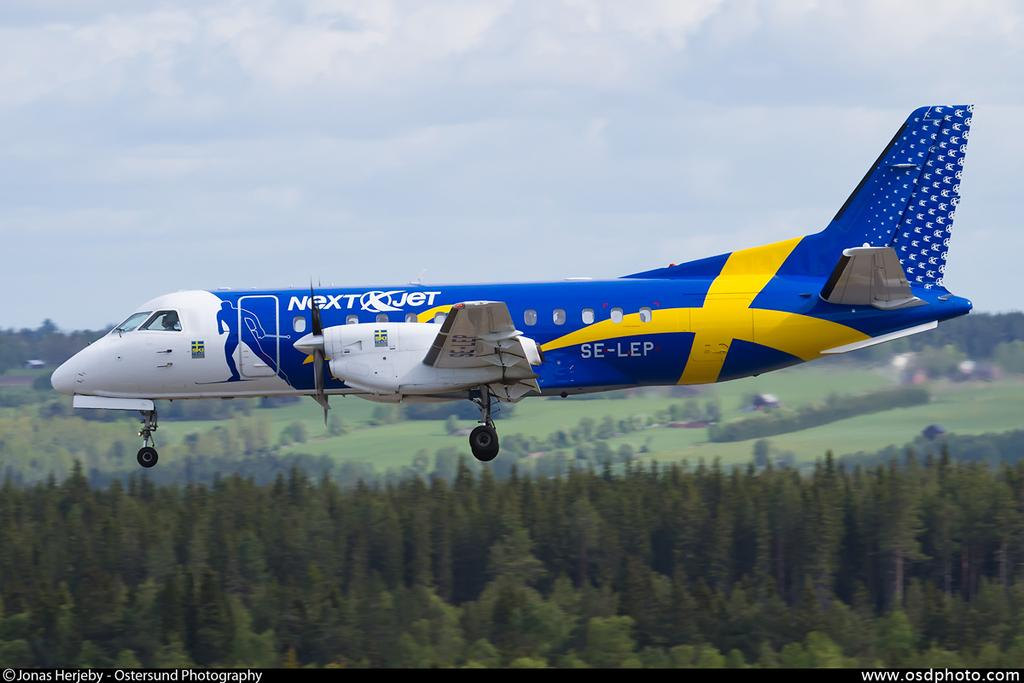What is the main subject of the image? The main subject of the image is an airplane. Where is the airplane located in the image? The airplane is in the air. What can be seen in the background of the image? There are trees, grass, and the sky visible in the background of the image. What is the condition of the sky in the image? The sky has clouds in it. What type of wall can be seen in the image? There is no wall present in the image; it features an airplane in the sky. How many birds are flying alongside the airplane in the image? There are no birds visible in the image; it only shows an airplane in the sky. 